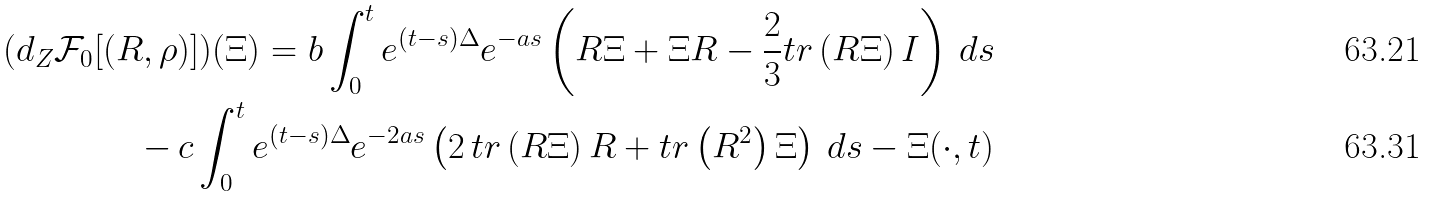<formula> <loc_0><loc_0><loc_500><loc_500>( d _ { Z } \mathcal { F } _ { 0 } [ ( R , \rho ) ] ) ( \Xi ) = b \int _ { 0 } ^ { t } e ^ { ( t - s ) \Delta } e ^ { - a s } \left ( R \Xi + \Xi R - \frac { 2 } { 3 } t r \left ( R \Xi \right ) I \right ) \, d s \\ - \, c \int _ { 0 } ^ { t } e ^ { ( t - s ) \Delta } e ^ { - 2 a s } \left ( 2 \, t r \left ( R \Xi \right ) R + t r \left ( R ^ { 2 } \right ) \Xi \right ) \, d s - \Xi ( \cdot , t )</formula> 